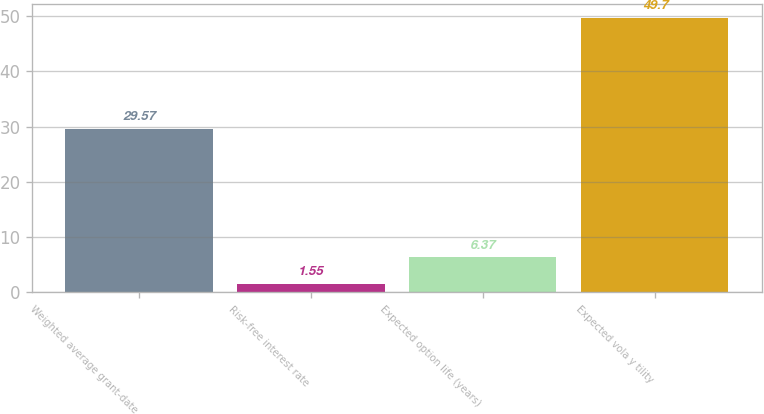Convert chart. <chart><loc_0><loc_0><loc_500><loc_500><bar_chart><fcel>Weighted average grant-date<fcel>Risk-free interest rate<fcel>Expected option life (years)<fcel>Expected vola y tility<nl><fcel>29.57<fcel>1.55<fcel>6.37<fcel>49.7<nl></chart> 